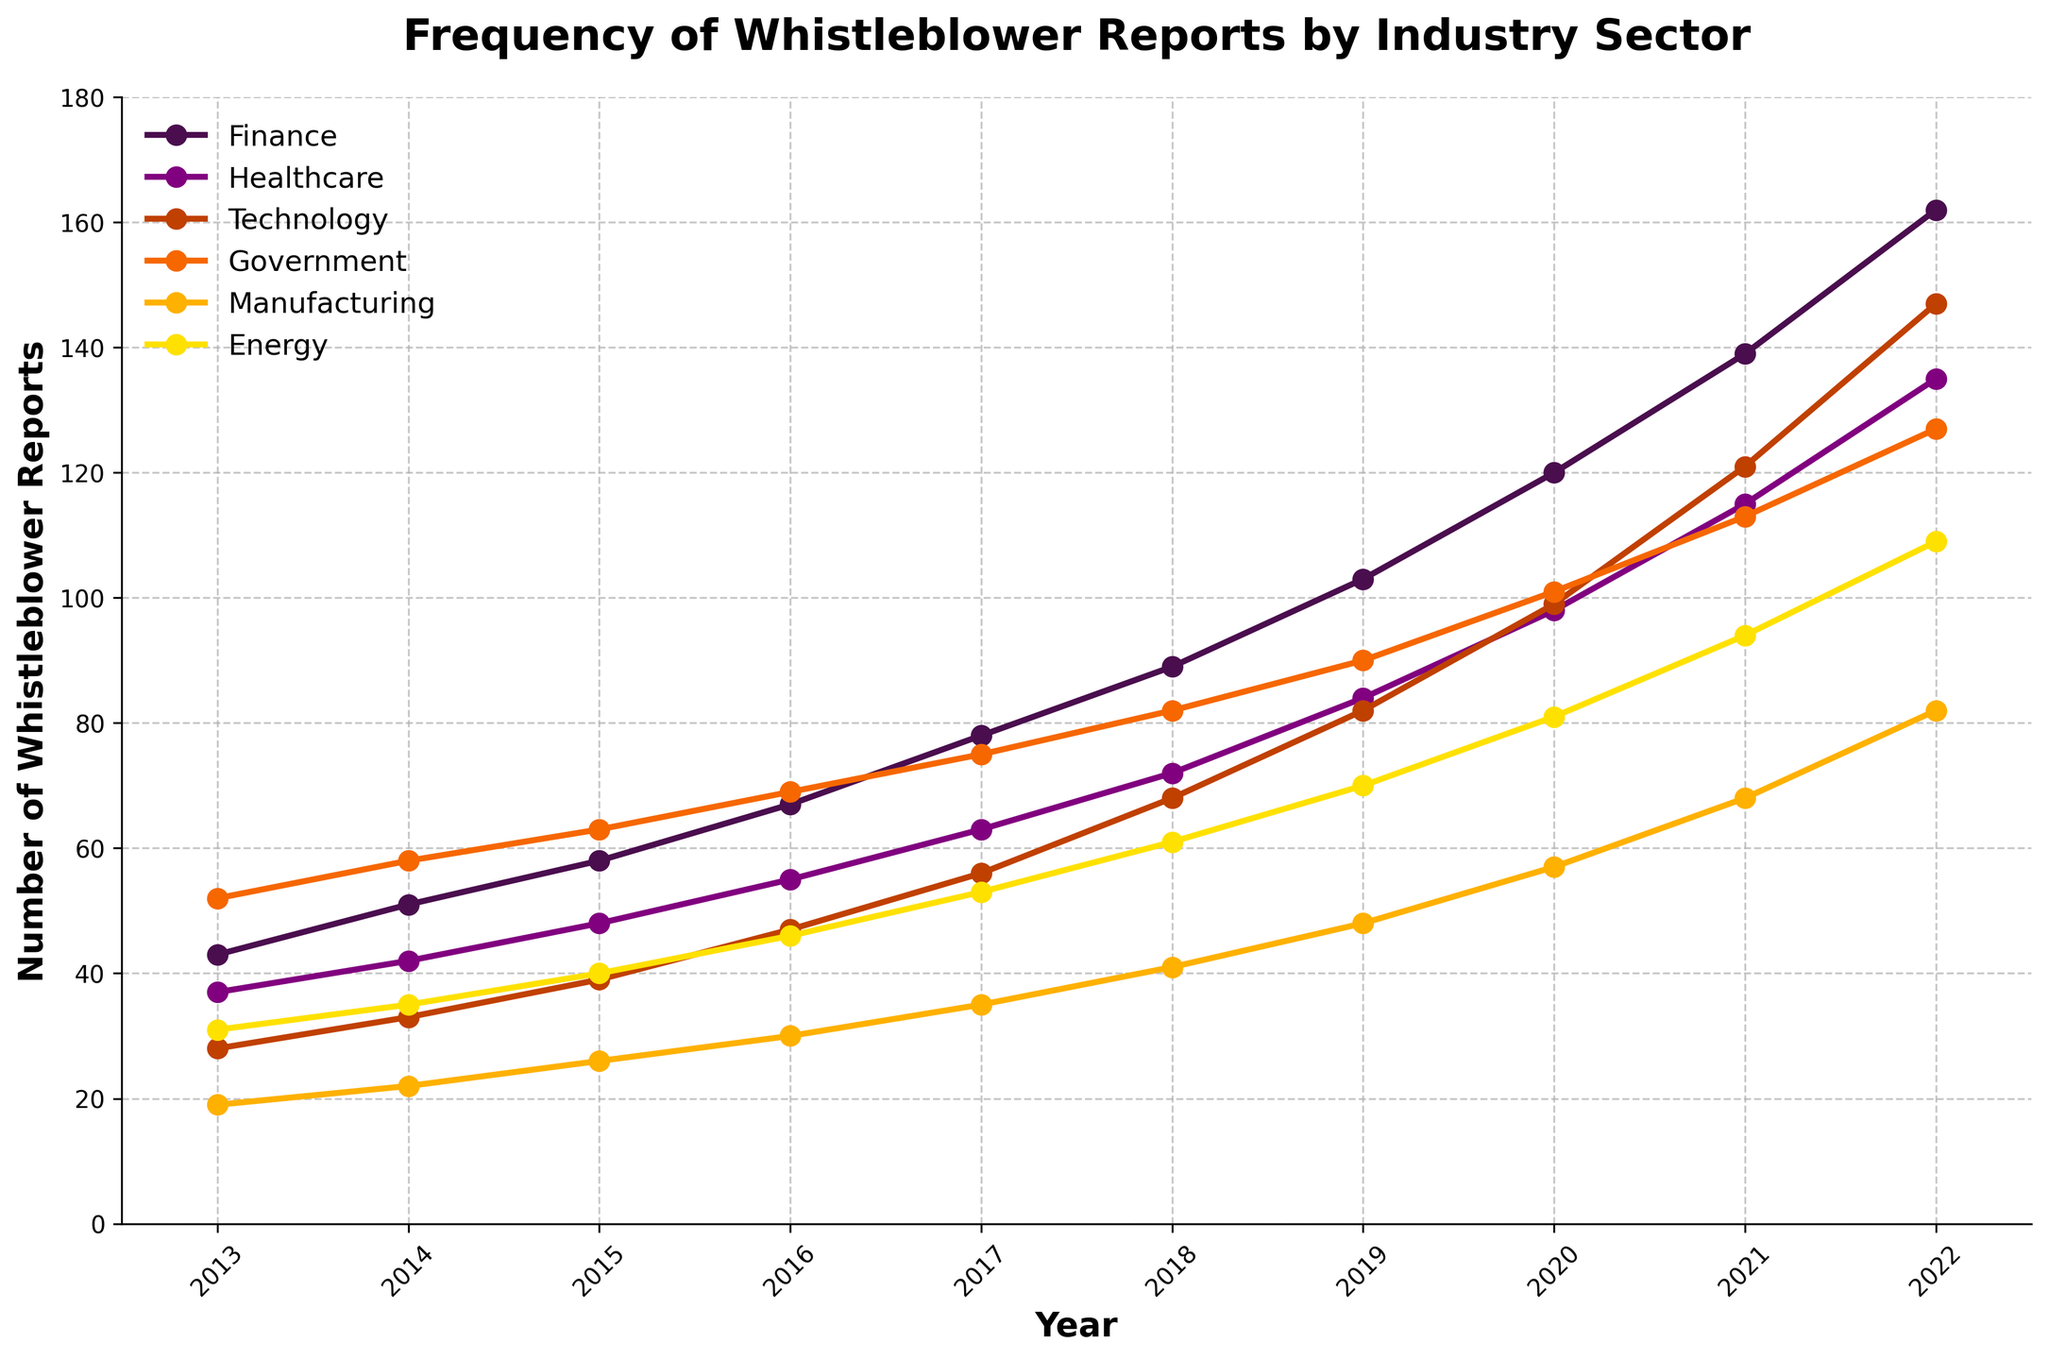What was the industry with the highest number of whistleblower reports in 2022? In 2022, the highest line on the graph corresponds to the Finance sector.
Answer: Finance By how much did the number of whistleblower reports in the Technology sector increase from 2013 to 2022? The number of reports in the Technology sector in 2013 was 28 and in 2022 it was 147. The difference is 147 - 28.
Answer: 119 Which industry experienced the smallest total increase in whistleblower reports from 2013 to 2022? By calculating the difference for each industry between 2013 and 2022, the smallest difference is found in the Manufacturing sector, where the increase is from 19 to 82.
Answer: Manufacturing Between 2013 and 2022, which year showed the most significant single-year increase in reports for the Healthcare sector? By examining the points for the Healthcare sector, the largest jump is observed between 2020 (98) and 2021 (115).
Answer: 2021 How many years did it take for the Energy sector to reach at least 100 reports starting from the initial year? The Energy sector reached at least 100 reports by 2022, starting from 31 reports in 2013, which took 9 years.
Answer: 9 years Which two sectors' growth in reports between 2018 and 2020 appears to be parallel? The trajectories for the Government and Technology sectors show a similar slope between 2018 and 2020.
Answer: Government, Technology What is the average number of whistleblower reports in the Manufacturing sector from 2013 to 2022? Sum the values from 2013 to 2022 and divide by the number of years: (19 + 22 + 26 + 30 + 35 + 41 + 48 + 57 + 68 + 82) / 10.
Answer: 41.8 Which industry shows the most linear trend in the increase of whistleblower reports over the decade? By examining the slopes of the lines, the Finance sector shows a consistent linear increase.
Answer: Finance Are there any years when the Energy sector had more whistleblower reports than the Manufacturing sector? Compare the values year by year; the Energy sector reported more in 2020, 2021, and 2022.
Answer: Yes Given the data, predict the industry most likely to have the highest growth rate in the next year and justify why. Judging by the trend and rate of increase over the years, the Technology sector, which shows an accelerating growth pattern, is most likely to have the highest growth rate.
Answer: Technology 